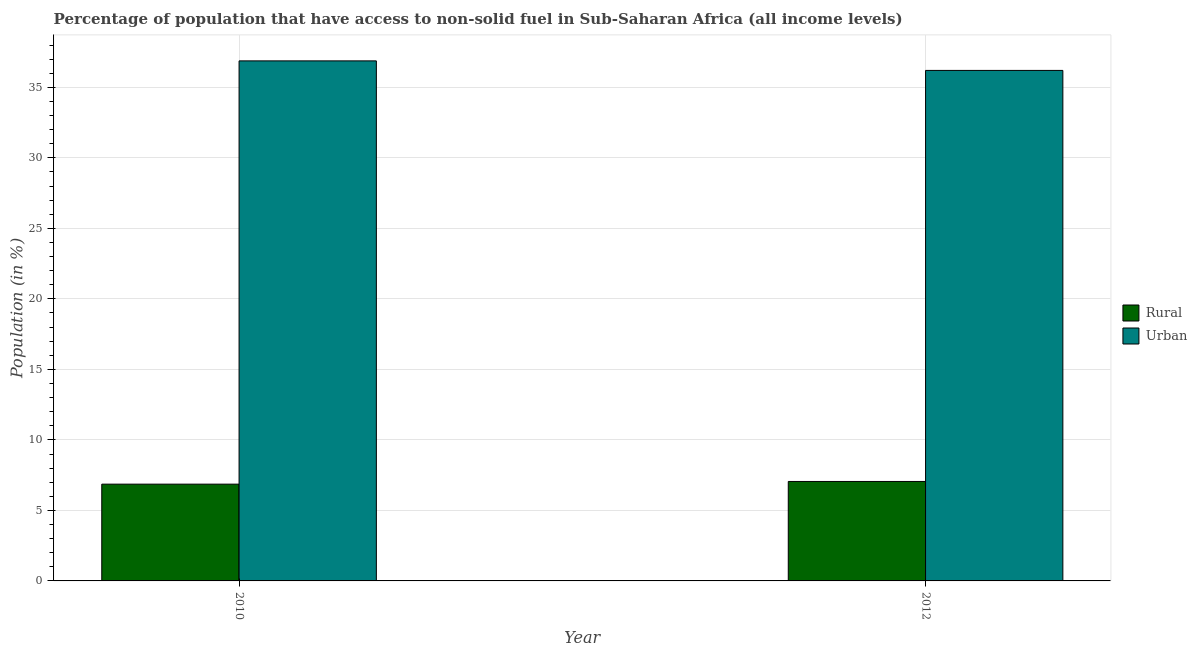How many different coloured bars are there?
Keep it short and to the point. 2. How many groups of bars are there?
Give a very brief answer. 2. Are the number of bars per tick equal to the number of legend labels?
Ensure brevity in your answer.  Yes. Are the number of bars on each tick of the X-axis equal?
Give a very brief answer. Yes. How many bars are there on the 2nd tick from the left?
Keep it short and to the point. 2. What is the label of the 2nd group of bars from the left?
Offer a very short reply. 2012. What is the rural population in 2012?
Offer a terse response. 7.05. Across all years, what is the maximum rural population?
Give a very brief answer. 7.05. Across all years, what is the minimum urban population?
Make the answer very short. 36.2. What is the total urban population in the graph?
Provide a succinct answer. 73.08. What is the difference between the rural population in 2010 and that in 2012?
Provide a short and direct response. -0.19. What is the difference between the rural population in 2012 and the urban population in 2010?
Ensure brevity in your answer.  0.19. What is the average rural population per year?
Offer a very short reply. 6.96. What is the ratio of the urban population in 2010 to that in 2012?
Make the answer very short. 1.02. In how many years, is the urban population greater than the average urban population taken over all years?
Provide a succinct answer. 1. What does the 2nd bar from the left in 2012 represents?
Your answer should be compact. Urban. What does the 1st bar from the right in 2010 represents?
Provide a succinct answer. Urban. How many bars are there?
Your answer should be very brief. 4. Are all the bars in the graph horizontal?
Ensure brevity in your answer.  No. How many years are there in the graph?
Your answer should be very brief. 2. Does the graph contain any zero values?
Ensure brevity in your answer.  No. Where does the legend appear in the graph?
Give a very brief answer. Center right. How many legend labels are there?
Provide a succinct answer. 2. What is the title of the graph?
Make the answer very short. Percentage of population that have access to non-solid fuel in Sub-Saharan Africa (all income levels). What is the label or title of the X-axis?
Your response must be concise. Year. What is the Population (in %) of Rural in 2010?
Offer a terse response. 6.86. What is the Population (in %) of Urban in 2010?
Offer a terse response. 36.88. What is the Population (in %) of Rural in 2012?
Your answer should be very brief. 7.05. What is the Population (in %) of Urban in 2012?
Give a very brief answer. 36.2. Across all years, what is the maximum Population (in %) of Rural?
Give a very brief answer. 7.05. Across all years, what is the maximum Population (in %) of Urban?
Make the answer very short. 36.88. Across all years, what is the minimum Population (in %) of Rural?
Keep it short and to the point. 6.86. Across all years, what is the minimum Population (in %) of Urban?
Your answer should be very brief. 36.2. What is the total Population (in %) in Rural in the graph?
Keep it short and to the point. 13.92. What is the total Population (in %) in Urban in the graph?
Make the answer very short. 73.08. What is the difference between the Population (in %) in Rural in 2010 and that in 2012?
Make the answer very short. -0.19. What is the difference between the Population (in %) in Urban in 2010 and that in 2012?
Your answer should be very brief. 0.68. What is the difference between the Population (in %) in Rural in 2010 and the Population (in %) in Urban in 2012?
Provide a short and direct response. -29.34. What is the average Population (in %) in Rural per year?
Make the answer very short. 6.96. What is the average Population (in %) in Urban per year?
Your response must be concise. 36.54. In the year 2010, what is the difference between the Population (in %) in Rural and Population (in %) in Urban?
Your answer should be very brief. -30.02. In the year 2012, what is the difference between the Population (in %) of Rural and Population (in %) of Urban?
Give a very brief answer. -29.15. What is the ratio of the Population (in %) of Rural in 2010 to that in 2012?
Your response must be concise. 0.97. What is the ratio of the Population (in %) in Urban in 2010 to that in 2012?
Ensure brevity in your answer.  1.02. What is the difference between the highest and the second highest Population (in %) of Rural?
Your response must be concise. 0.19. What is the difference between the highest and the second highest Population (in %) of Urban?
Keep it short and to the point. 0.68. What is the difference between the highest and the lowest Population (in %) in Rural?
Your answer should be compact. 0.19. What is the difference between the highest and the lowest Population (in %) in Urban?
Keep it short and to the point. 0.68. 